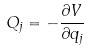Convert formula to latex. <formula><loc_0><loc_0><loc_500><loc_500>Q _ { j } = - \frac { \partial V } { \partial q _ { j } }</formula> 